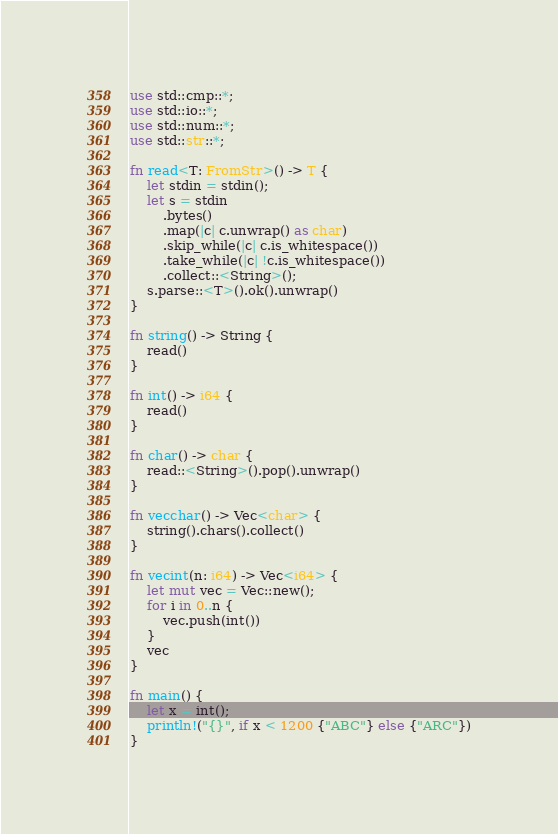<code> <loc_0><loc_0><loc_500><loc_500><_Rust_>use std::cmp::*;
use std::io::*;
use std::num::*;
use std::str::*;

fn read<T: FromStr>() -> T {
    let stdin = stdin();
    let s = stdin
        .bytes()
        .map(|c| c.unwrap() as char)
        .skip_while(|c| c.is_whitespace())
        .take_while(|c| !c.is_whitespace())
        .collect::<String>();
    s.parse::<T>().ok().unwrap()
}

fn string() -> String {
    read()
}

fn int() -> i64 {
    read()
}

fn char() -> char {
    read::<String>().pop().unwrap()
}

fn vecchar() -> Vec<char> {
    string().chars().collect()
}

fn vecint(n: i64) -> Vec<i64> {
    let mut vec = Vec::new();
    for i in 0..n {
        vec.push(int())
    }
    vec
}

fn main() {
    let x = int();
    println!("{}", if x < 1200 {"ABC"} else {"ARC"})
}
</code> 